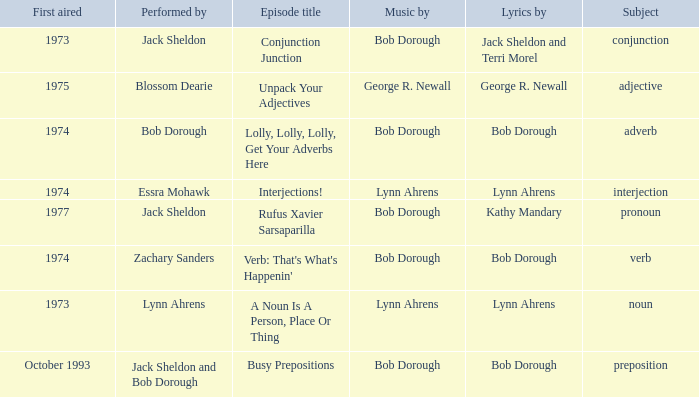Give me the full table as a dictionary. {'header': ['First aired', 'Performed by', 'Episode title', 'Music by', 'Lyrics by', 'Subject'], 'rows': [['1973', 'Jack Sheldon', 'Conjunction Junction', 'Bob Dorough', 'Jack Sheldon and Terri Morel', 'conjunction'], ['1975', 'Blossom Dearie', 'Unpack Your Adjectives', 'George R. Newall', 'George R. Newall', 'adjective'], ['1974', 'Bob Dorough', 'Lolly, Lolly, Lolly, Get Your Adverbs Here', 'Bob Dorough', 'Bob Dorough', 'adverb'], ['1974', 'Essra Mohawk', 'Interjections!', 'Lynn Ahrens', 'Lynn Ahrens', 'interjection'], ['1977', 'Jack Sheldon', 'Rufus Xavier Sarsaparilla', 'Bob Dorough', 'Kathy Mandary', 'pronoun'], ['1974', 'Zachary Sanders', "Verb: That's What's Happenin'", 'Bob Dorough', 'Bob Dorough', 'verb'], ['1973', 'Lynn Ahrens', 'A Noun Is A Person, Place Or Thing', 'Lynn Ahrens', 'Lynn Ahrens', 'noun'], ['October 1993', 'Jack Sheldon and Bob Dorough', 'Busy Prepositions', 'Bob Dorough', 'Bob Dorough', 'preposition']]} When zachary sanders is the performer how many people is the music by? 1.0. 